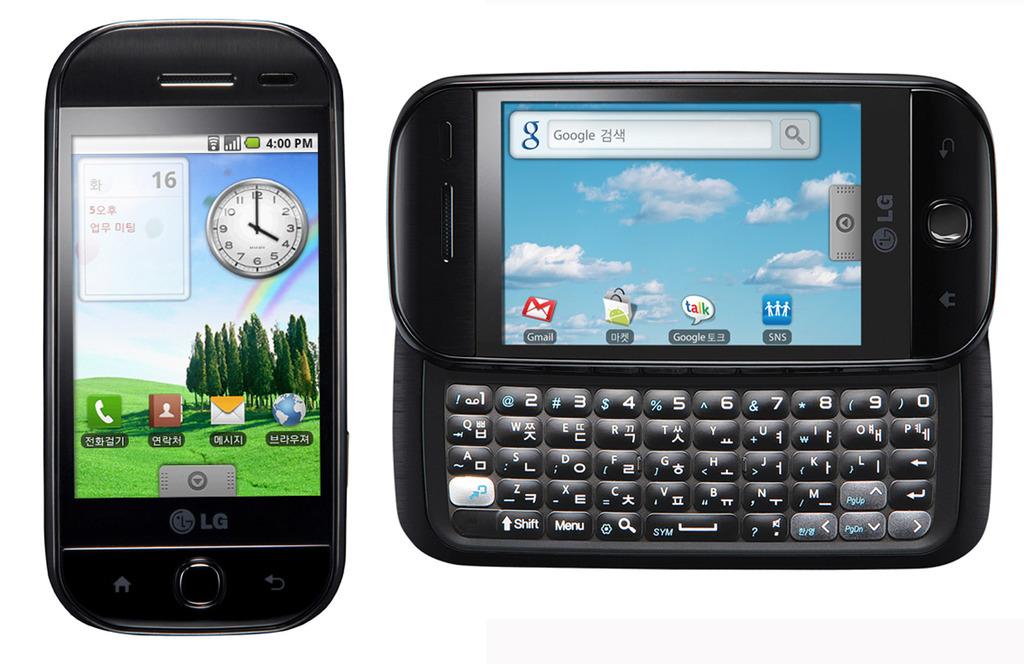What search engine is on the phone?
Provide a succinct answer. Google. Is that a calculator besides the phone?
Your answer should be compact. No. 